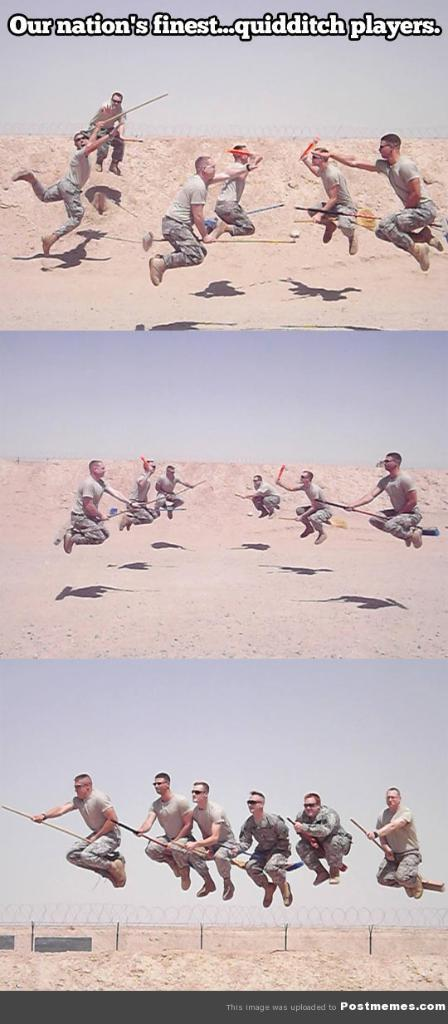Provide a one-sentence caption for the provided image. groups of men flying on brooms outdoors playing a game of quidditch. 